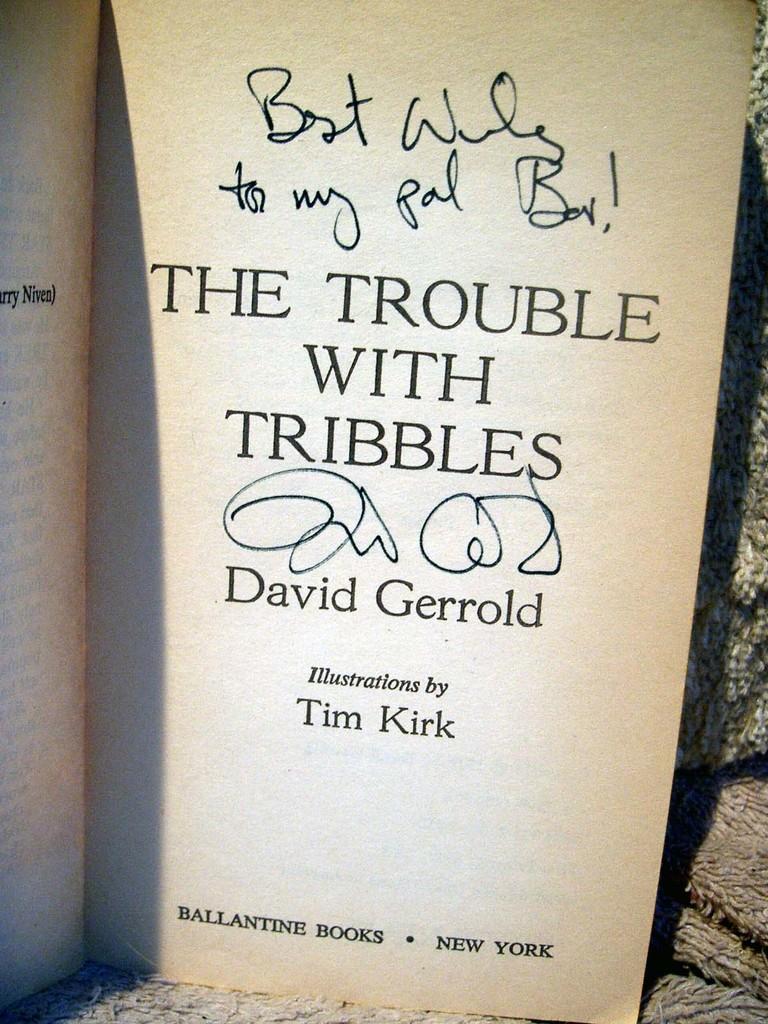Who illustrated the book?
Keep it short and to the point. Tim kirk. Who authored the book?
Your answer should be compact. David gerrold. 